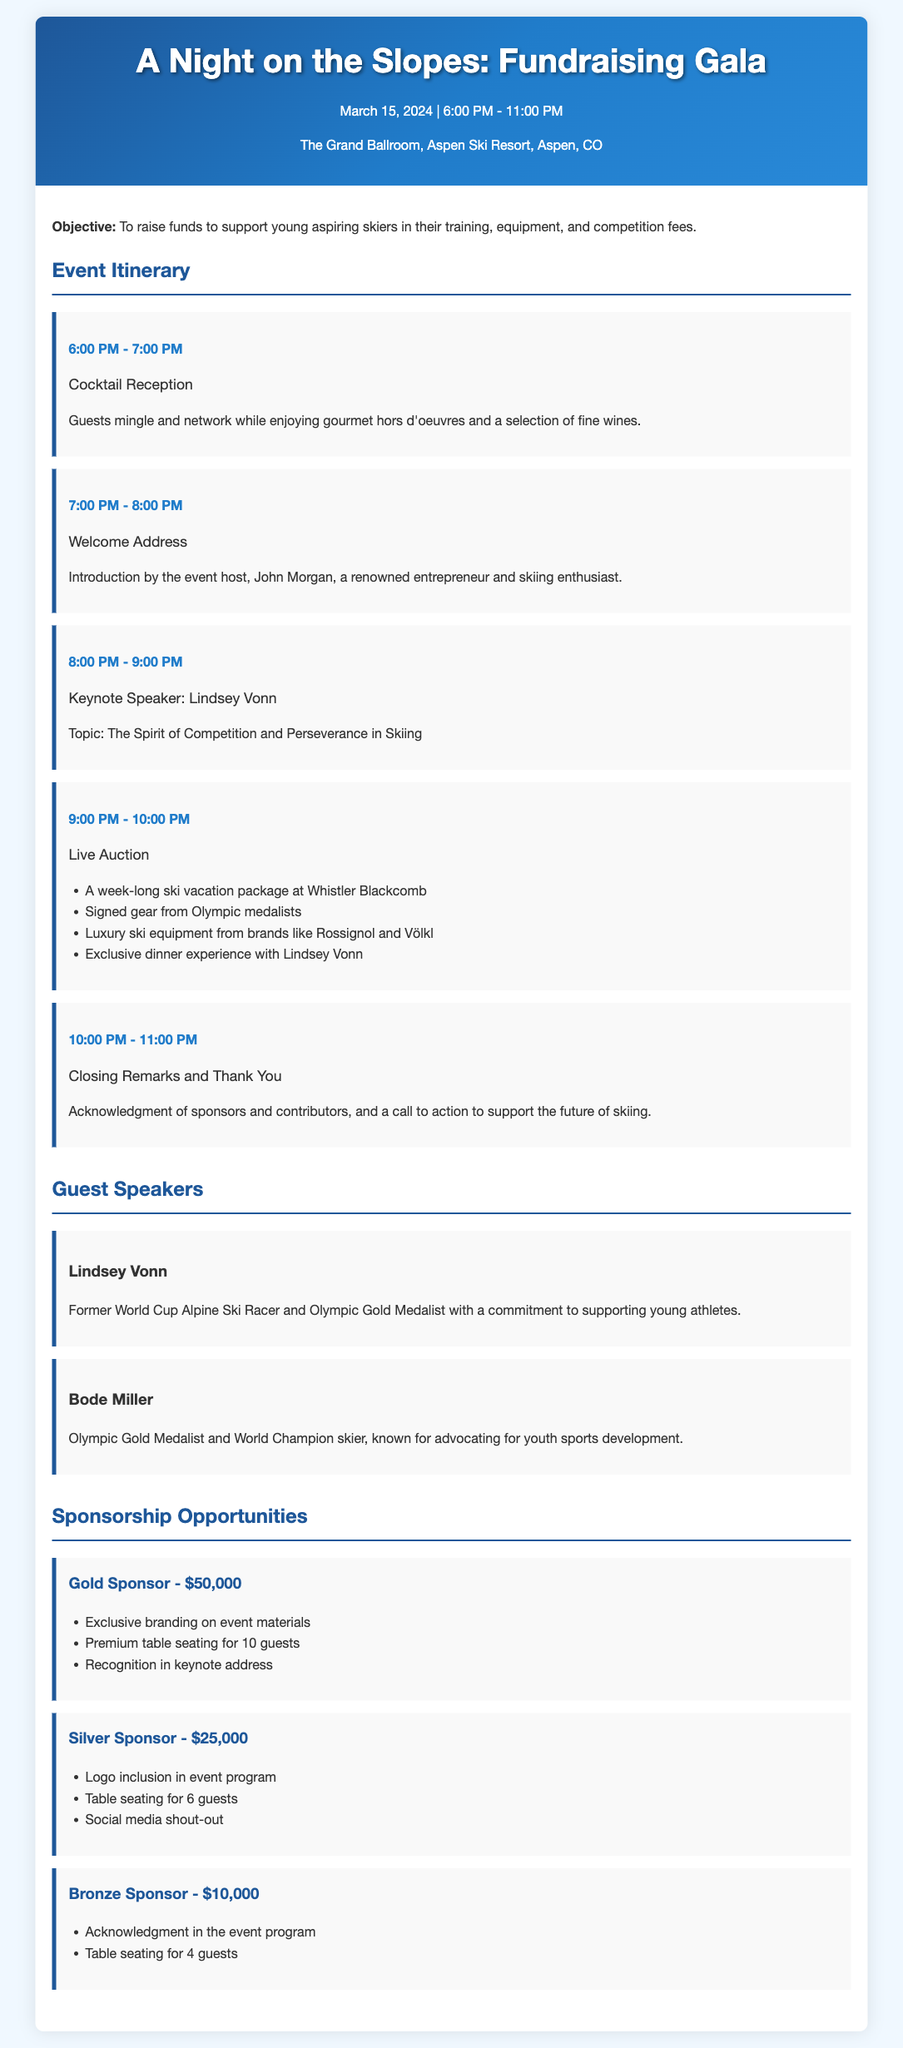What is the date of the gala? The date is specifically mentioned in the header of the document.
Answer: March 15, 2024 Who is the keynote speaker? The document lists Lindsey Vonn as the keynote speaker in the itinerary section.
Answer: Lindsey Vonn What time does the cocktail reception start? The starting time is detailed in the event itinerary.
Answer: 6:00 PM How much is the Gold Sponsorship? The amount is specified in the sponsorship opportunities section of the document.
Answer: $50,000 What is the topic of Lindsey Vonn's speech? The topic is clearly stated under the keynote speaker section.
Answer: The Spirit of Competition and Perseverance in Skiing What activity occurs between 9:00 PM and 10:00 PM? This activity is listed in the itinerary, detailing the events occurring during that hour.
Answer: Live Auction How many guests does the Silver Sponsorship allow? The number of guests is mentioned in the sponsorship opportunities section for the Silver Sponsor.
Answer: 6 guests What type of auction item is featured for a week-long vacation? The document includes specific items in the auction list found in the itinerary.
Answer: A week-long ski vacation package at Whistler Blackcomb Who is the host of the welcome address? The host's name is noted in the welcome address part of the itinerary.
Answer: John Morgan 